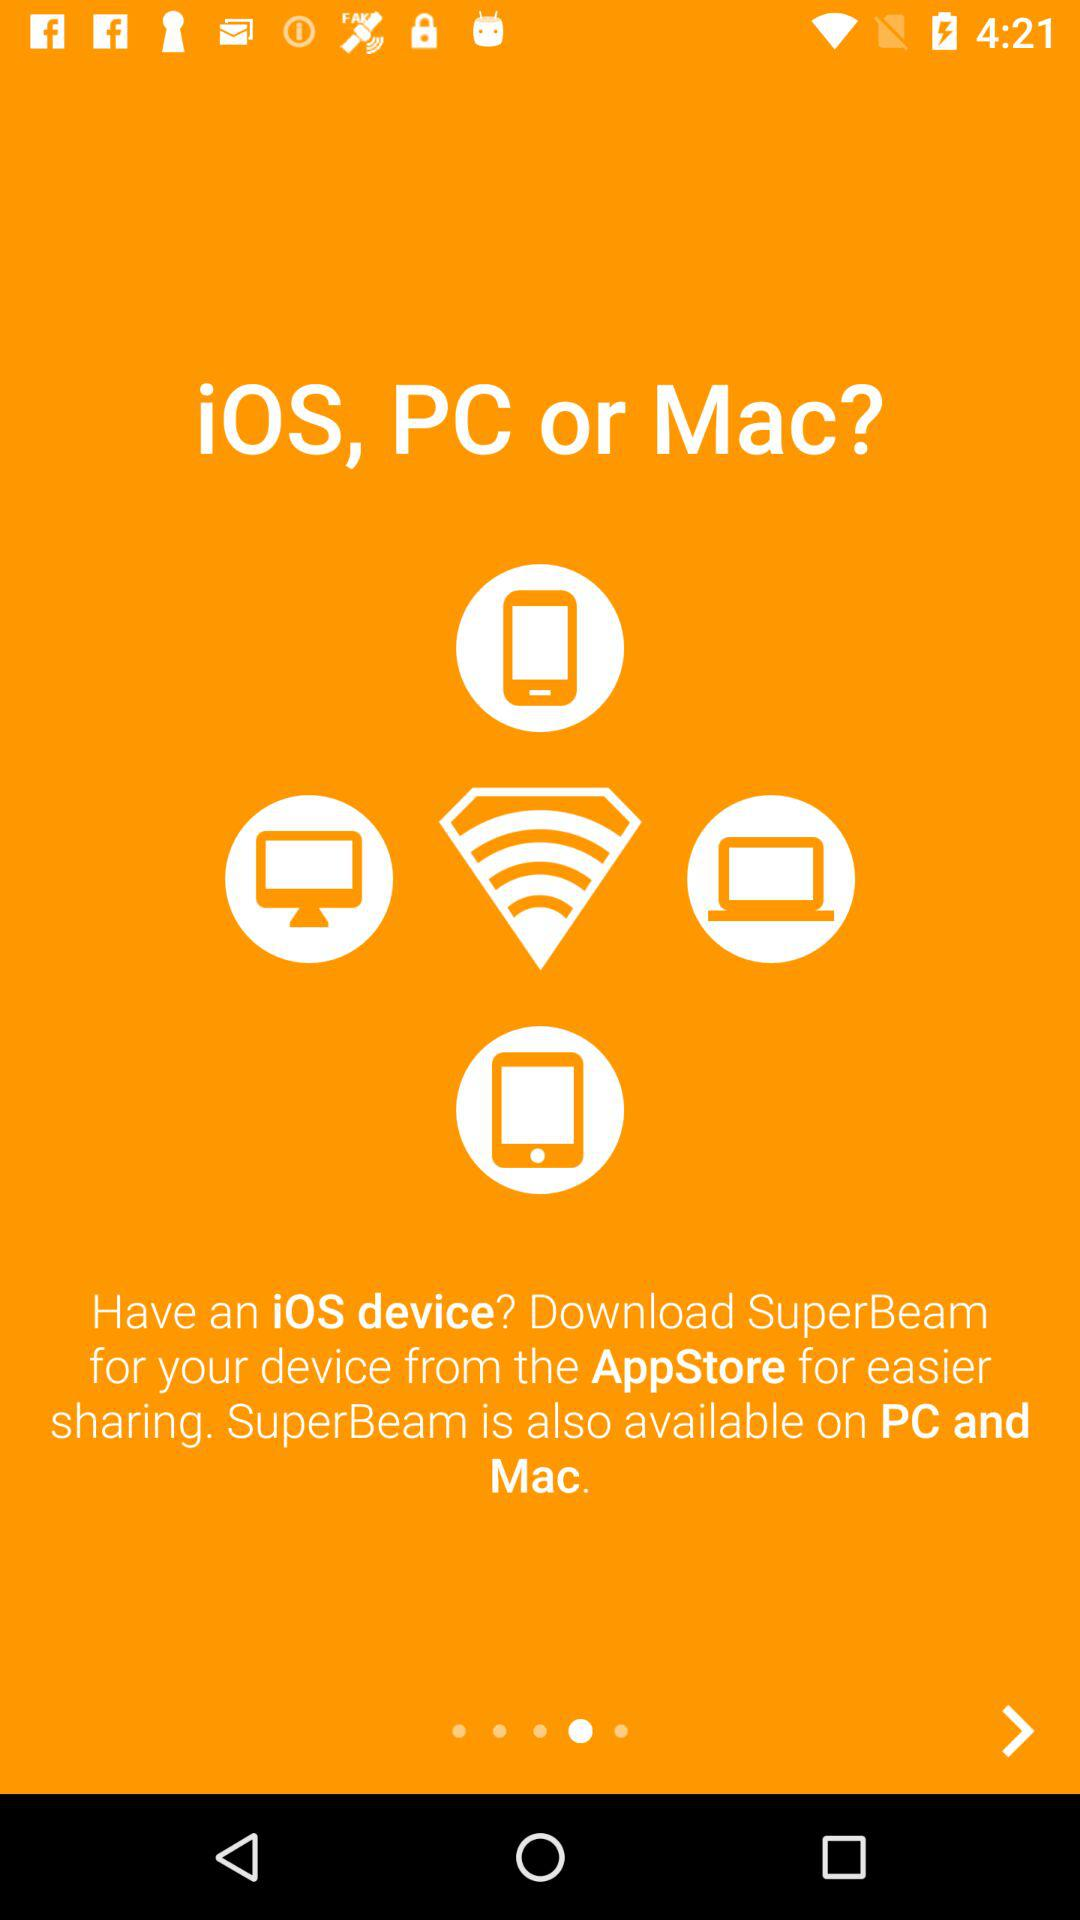How many devices are available for SuperBeam?
Answer the question using a single word or phrase. 3 